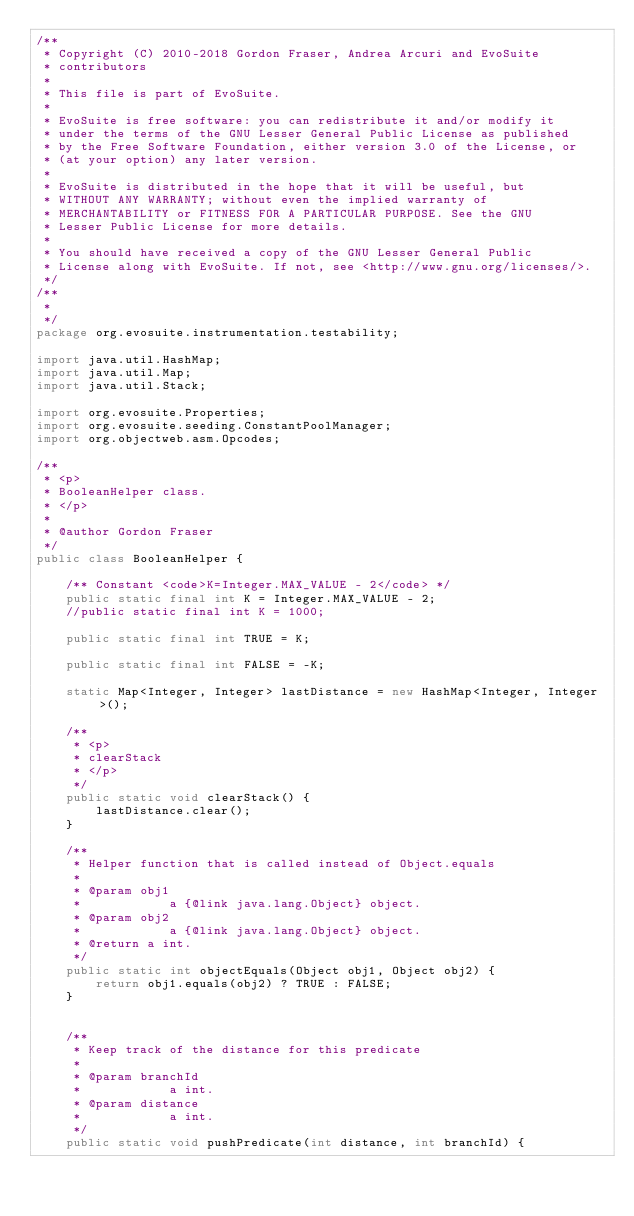<code> <loc_0><loc_0><loc_500><loc_500><_Java_>/**
 * Copyright (C) 2010-2018 Gordon Fraser, Andrea Arcuri and EvoSuite
 * contributors
 *
 * This file is part of EvoSuite.
 *
 * EvoSuite is free software: you can redistribute it and/or modify it
 * under the terms of the GNU Lesser General Public License as published
 * by the Free Software Foundation, either version 3.0 of the License, or
 * (at your option) any later version.
 *
 * EvoSuite is distributed in the hope that it will be useful, but
 * WITHOUT ANY WARRANTY; without even the implied warranty of
 * MERCHANTABILITY or FITNESS FOR A PARTICULAR PURPOSE. See the GNU
 * Lesser Public License for more details.
 *
 * You should have received a copy of the GNU Lesser General Public
 * License along with EvoSuite. If not, see <http://www.gnu.org/licenses/>.
 */
/**
 * 
 */
package org.evosuite.instrumentation.testability;

import java.util.HashMap;
import java.util.Map;
import java.util.Stack;

import org.evosuite.Properties;
import org.evosuite.seeding.ConstantPoolManager;
import org.objectweb.asm.Opcodes;

/**
 * <p>
 * BooleanHelper class.
 * </p>
 * 
 * @author Gordon Fraser
 */
public class BooleanHelper {

	/** Constant <code>K=Integer.MAX_VALUE - 2</code> */
	public static final int K = Integer.MAX_VALUE - 2;
	//public static final int K = 1000;

    public static final int TRUE = K;

    public static final int FALSE = -K;

    static Map<Integer, Integer> lastDistance = new HashMap<Integer, Integer>();

	/**
	 * <p>
	 * clearStack
	 * </p>
	 */
	public static void clearStack() {
		lastDistance.clear();
	}

	/**
	 * Helper function that is called instead of Object.equals
	 * 
	 * @param obj1
	 *            a {@link java.lang.Object} object.
	 * @param obj2
	 *            a {@link java.lang.Object} object.
	 * @return a int.
	 */
	public static int objectEquals(Object obj1, Object obj2) {
		return obj1.equals(obj2) ? TRUE : FALSE;
	}


	/**
	 * Keep track of the distance for this predicate
	 * 
	 * @param branchId
	 *            a int.
	 * @param distance
	 *            a int.
	 */
	public static void pushPredicate(int distance, int branchId) {</code> 